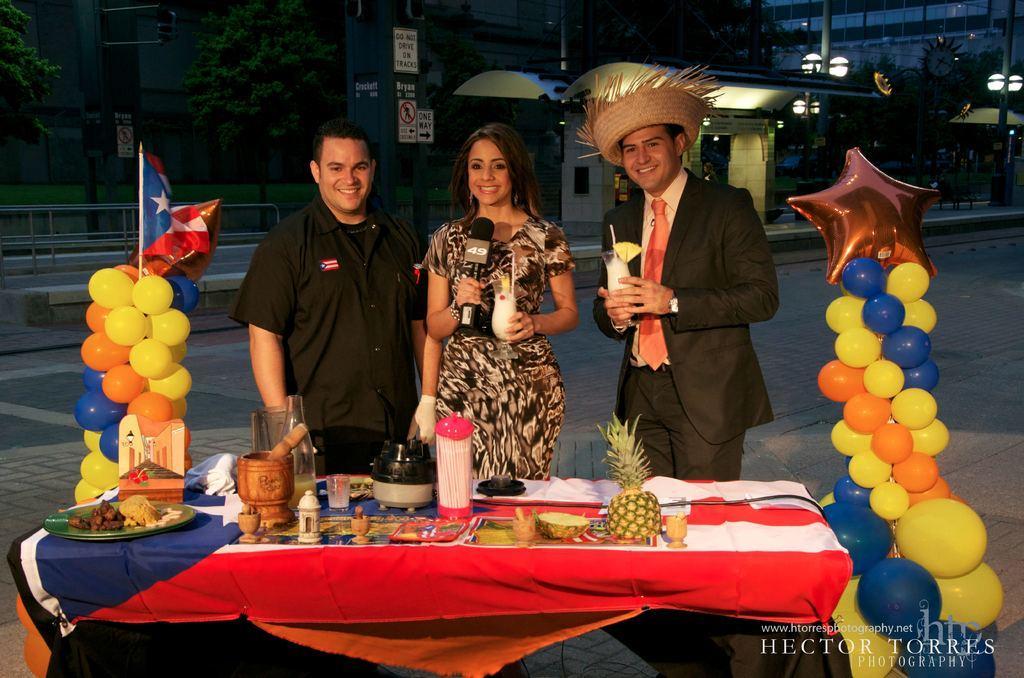Can you describe this image briefly? In this picture, we see three people standing on the road in front of the table and all of them are smiling. Woman in the middle of the picture wearing brown and white dress is holding microphone in one of her hands and in the other hand, she is holding a glass containing liquid. Beside her, man in black blazer is also holding a glass containing liquid in his hand and he is even wearing a hat. On the table, we see pineapple, plate containing food, bottle, glass and wooden items. On either side of them, we see balloons which are in yellow, orange and blue color. There are many trees and buildings in the background. This picture is clicked in the dark. 